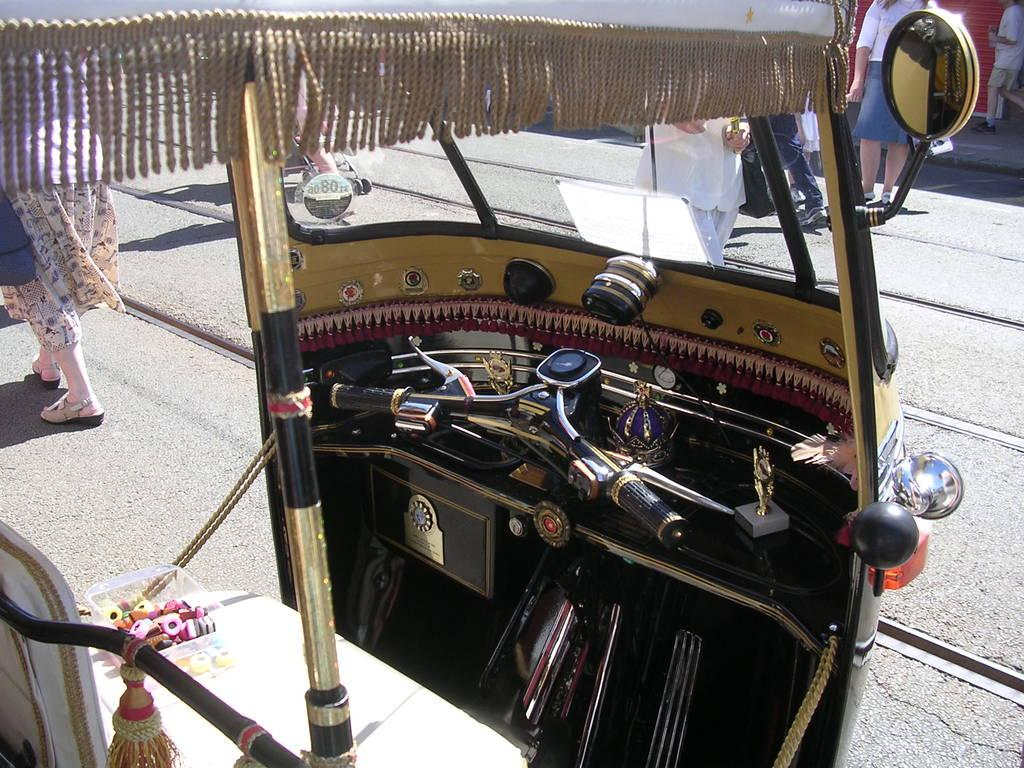What is on the road in the image? There is a vehicle on the road in the image. Can you describe the people in the image? Unfortunately, the facts provided do not give any details about the people in the image. What type of vehicle is on the road? The facts provided do not specify the type of vehicle on the road. How many bees are sitting on the tree in the image? There is no tree or bees present in the image. Is there a dock visible in the image? There is no dock present in the image. 